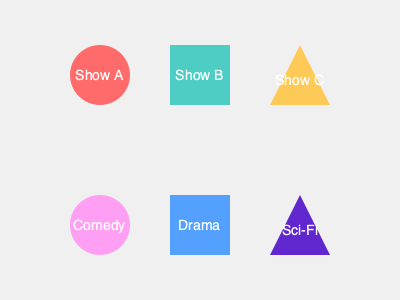As a television producer looking to showcase diverse talent, you're reviewing potential new shows. Match each TV show logo (A, B, C) to its corresponding genre symbol (Comedy, Drama, Sci-Fi) based on the visual cues provided. What is the correct pairing? To match the TV show logos to their corresponding genre symbols, we need to analyze the visual cues provided:

1. Show A: Represented by a circle, which is typically associated with lighthearted and fun content. This shape matches the Comedy genre symbol, also represented by a circle.

2. Show B: Represented by a square, which often signifies structure, stability, and seriousness. This shape aligns with the Drama genre symbol, also depicted as a square.

3. Show C: Represented by a triangle, which is commonly used to symbolize futuristic or otherworldly concepts. This shape corresponds to the Sci-Fi genre symbol, also shown as a triangle.

By matching the shapes of the show logos to the genre symbols, we can deduce the correct pairing:

- Show A (circle) pairs with Comedy (circle)
- Show B (square) pairs with Drama (square)
- Show C (triangle) pairs with Sci-Fi (triangle)
Answer: A-Comedy, B-Drama, C-Sci-Fi 